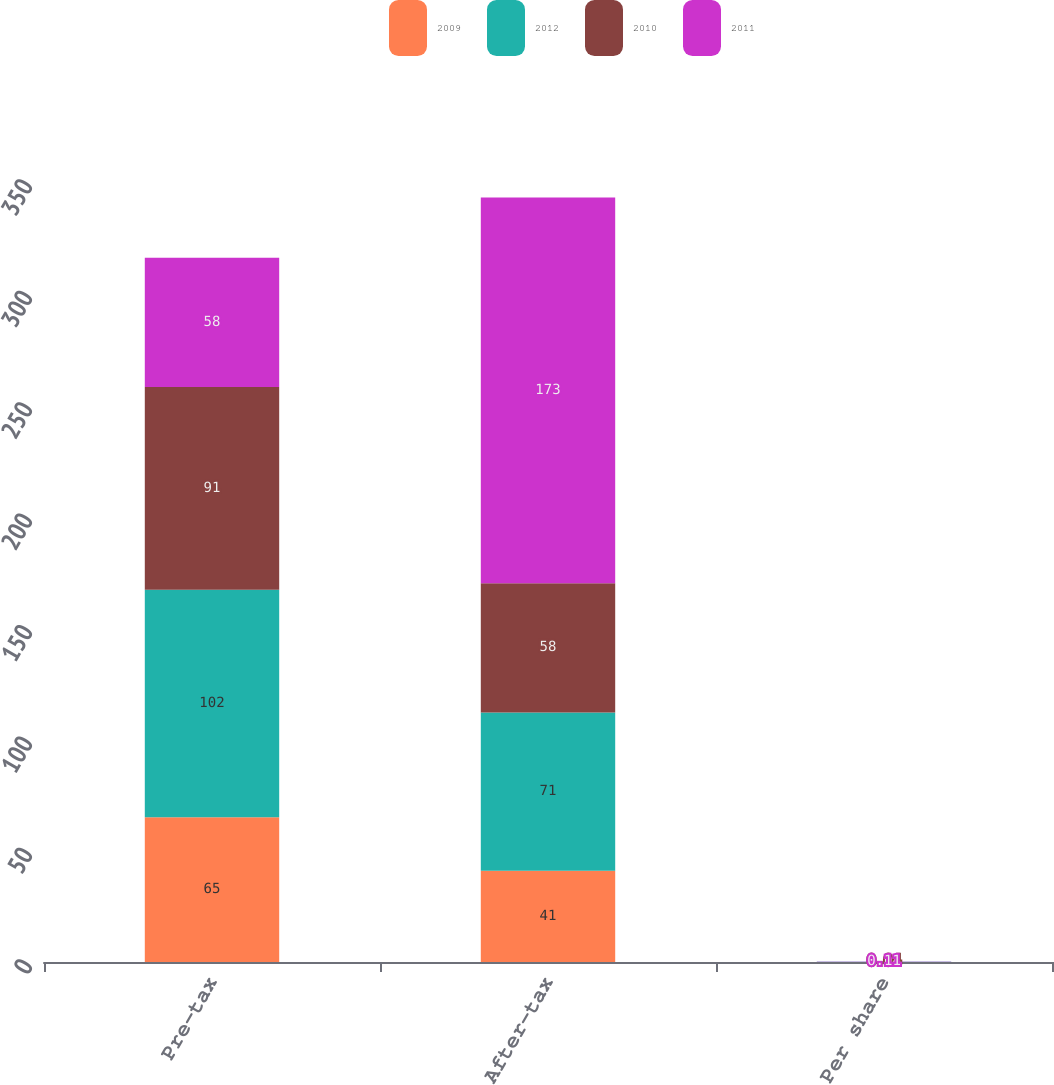Convert chart to OTSL. <chart><loc_0><loc_0><loc_500><loc_500><stacked_bar_chart><ecel><fcel>Pre-tax<fcel>After-tax<fcel>Per share<nl><fcel>2009<fcel>65<fcel>41<fcel>0.03<nl><fcel>2012<fcel>102<fcel>71<fcel>0.04<nl><fcel>2010<fcel>91<fcel>58<fcel>0.04<nl><fcel>2011<fcel>58<fcel>173<fcel>0.11<nl></chart> 